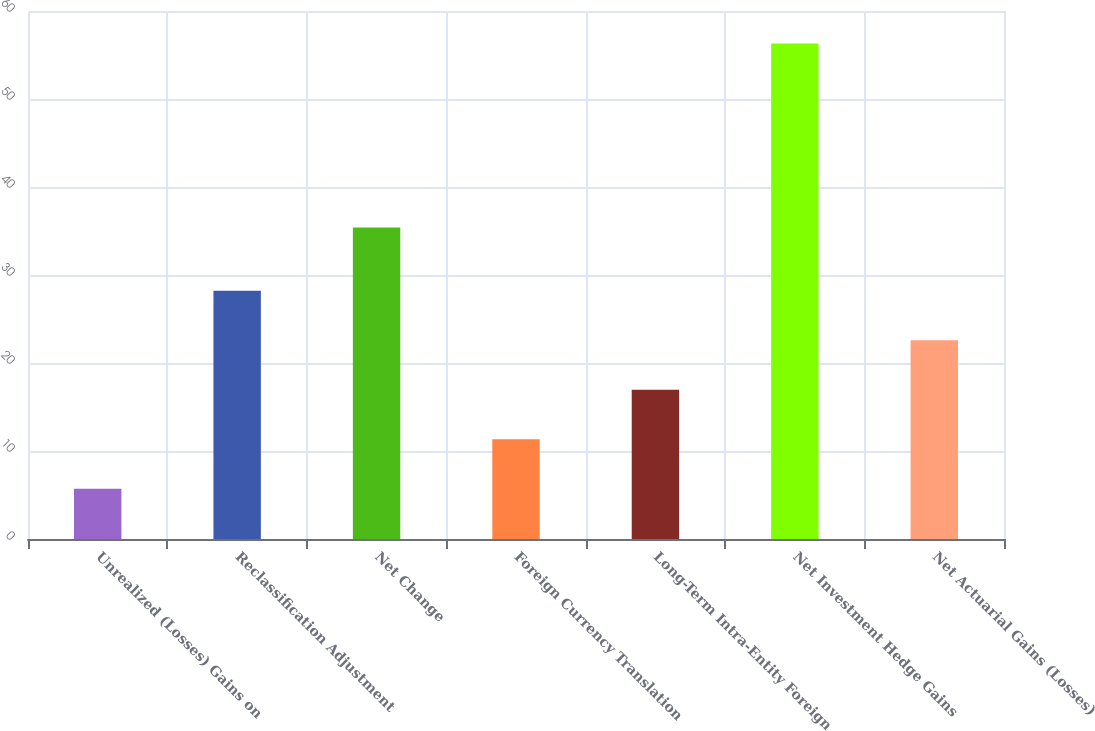Convert chart. <chart><loc_0><loc_0><loc_500><loc_500><bar_chart><fcel>Unrealized (Losses) Gains on<fcel>Reclassification Adjustment<fcel>Net Change<fcel>Foreign Currency Translation<fcel>Long-Term Intra-Entity Foreign<fcel>Net Investment Hedge Gains<fcel>Net Actuarial Gains (Losses)<nl><fcel>5.72<fcel>28.2<fcel>35.4<fcel>11.34<fcel>16.96<fcel>56.3<fcel>22.58<nl></chart> 